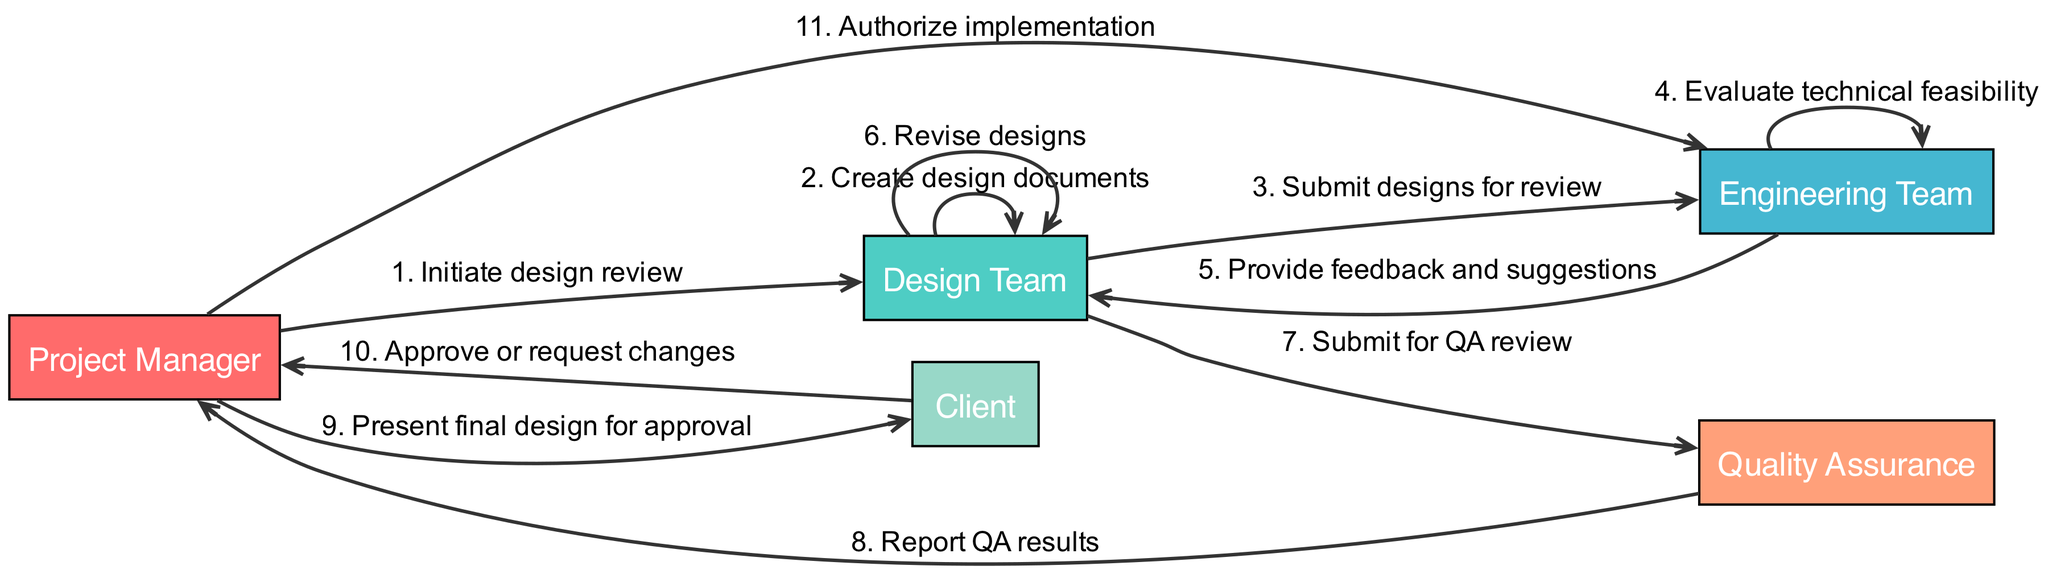What is the first action in the sequence? The first action in the sequence comes from the Project Manager to the Design Team, and it is "Initiate design review."
Answer: Initiate design review How many actors are involved in the process? By counting the distinct actors listed at the top of the diagram, we see there are 5 actors: Project Manager, Design Team, Engineering Team, Quality Assurance, and Client.
Answer: 5 Which team submits designs for review? According to the diagram, the Design Team is responsible for submitting the designs to the Engineering Team for review.
Answer: Design Team What action follows the "Provide feedback and suggestions"? Following the feedback from the Engineering Team, the next action is for the Design Team to "Revise designs." This shows the iterative nature of the review process.
Answer: Revise designs How many actions are performed by the Engineering Team? The Engineering Team performs two actions: "Evaluate technical feasibility" and "Provide feedback and suggestions." Therefore, we have a total of 2 actions.
Answer: 2 Who is responsible for authorizing implementation? The Project Manager is the actor that authorizes implementation as stated in the last action of the sequence.
Answer: Project Manager What happens after QA review results are reported? After the Quality Assurance reviews and reports the results to the Project Manager, the Project Manager then presents the final design to the Client for approval.
Answer: Present final design for approval What action occurs after the Client approves or requests changes? After the Client either approves or requests changes, the Project Manager will either proceed with implementation or address the requested changes. The next logical action based on approval is "Authorize implementation."
Answer: Authorize implementation What is the connection between the Design Team and the Quality Assurance team? The connection between the Design Team and the Quality Assurance team is established when the Design Team submits designs for a QA review, indicating a flow of information for quality assessment.
Answer: Submit for QA review 